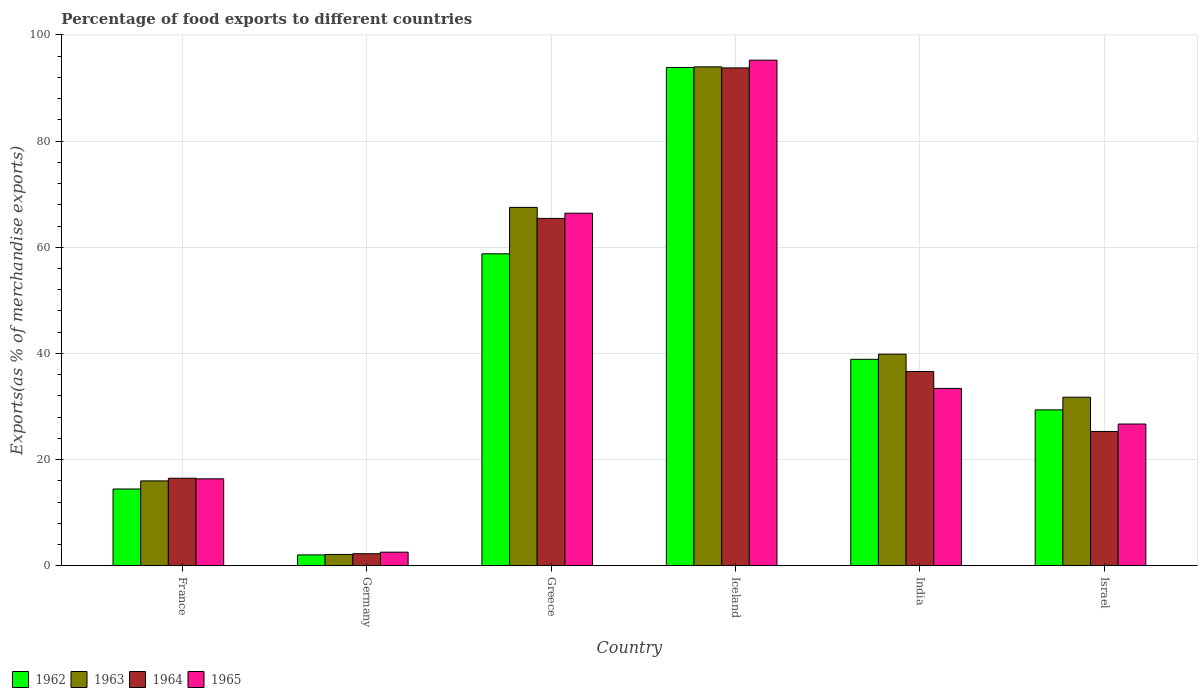How many different coloured bars are there?
Your answer should be very brief. 4. How many groups of bars are there?
Your answer should be compact. 6. Are the number of bars per tick equal to the number of legend labels?
Provide a succinct answer. Yes. What is the label of the 6th group of bars from the left?
Your response must be concise. Israel. What is the percentage of exports to different countries in 1964 in France?
Your answer should be very brief. 16.5. Across all countries, what is the maximum percentage of exports to different countries in 1964?
Provide a short and direct response. 93.79. Across all countries, what is the minimum percentage of exports to different countries in 1962?
Your response must be concise. 2.05. What is the total percentage of exports to different countries in 1962 in the graph?
Your answer should be compact. 237.43. What is the difference between the percentage of exports to different countries in 1963 in Germany and that in Israel?
Make the answer very short. -29.62. What is the difference between the percentage of exports to different countries in 1963 in India and the percentage of exports to different countries in 1965 in Germany?
Make the answer very short. 37.3. What is the average percentage of exports to different countries in 1964 per country?
Provide a short and direct response. 39.99. What is the difference between the percentage of exports to different countries of/in 1962 and percentage of exports to different countries of/in 1964 in Iceland?
Offer a very short reply. 0.08. What is the ratio of the percentage of exports to different countries in 1964 in Greece to that in Iceland?
Offer a very short reply. 0.7. Is the percentage of exports to different countries in 1962 in India less than that in Israel?
Your answer should be compact. No. Is the difference between the percentage of exports to different countries in 1962 in France and Iceland greater than the difference between the percentage of exports to different countries in 1964 in France and Iceland?
Provide a short and direct response. No. What is the difference between the highest and the second highest percentage of exports to different countries in 1965?
Keep it short and to the point. -33.01. What is the difference between the highest and the lowest percentage of exports to different countries in 1962?
Ensure brevity in your answer.  91.82. Is it the case that in every country, the sum of the percentage of exports to different countries in 1963 and percentage of exports to different countries in 1965 is greater than the sum of percentage of exports to different countries in 1964 and percentage of exports to different countries in 1962?
Give a very brief answer. No. What does the 2nd bar from the left in Iceland represents?
Provide a short and direct response. 1963. What does the 1st bar from the right in India represents?
Ensure brevity in your answer.  1965. How many bars are there?
Offer a terse response. 24. How many countries are there in the graph?
Make the answer very short. 6. Does the graph contain any zero values?
Make the answer very short. No. Where does the legend appear in the graph?
Ensure brevity in your answer.  Bottom left. How many legend labels are there?
Give a very brief answer. 4. How are the legend labels stacked?
Your answer should be compact. Horizontal. What is the title of the graph?
Your answer should be compact. Percentage of food exports to different countries. Does "1977" appear as one of the legend labels in the graph?
Give a very brief answer. No. What is the label or title of the Y-axis?
Offer a very short reply. Exports(as % of merchandise exports). What is the Exports(as % of merchandise exports) in 1962 in France?
Make the answer very short. 14.46. What is the Exports(as % of merchandise exports) in 1963 in France?
Ensure brevity in your answer.  15.99. What is the Exports(as % of merchandise exports) in 1964 in France?
Make the answer very short. 16.5. What is the Exports(as % of merchandise exports) in 1965 in France?
Ensure brevity in your answer.  16.38. What is the Exports(as % of merchandise exports) of 1962 in Germany?
Provide a short and direct response. 2.05. What is the Exports(as % of merchandise exports) in 1963 in Germany?
Ensure brevity in your answer.  2.14. What is the Exports(as % of merchandise exports) of 1964 in Germany?
Ensure brevity in your answer.  2.27. What is the Exports(as % of merchandise exports) of 1965 in Germany?
Make the answer very short. 2.57. What is the Exports(as % of merchandise exports) in 1962 in Greece?
Offer a very short reply. 58.77. What is the Exports(as % of merchandise exports) in 1963 in Greece?
Your response must be concise. 67.52. What is the Exports(as % of merchandise exports) in 1964 in Greece?
Offer a very short reply. 65.45. What is the Exports(as % of merchandise exports) in 1965 in Greece?
Keep it short and to the point. 66.42. What is the Exports(as % of merchandise exports) of 1962 in Iceland?
Ensure brevity in your answer.  93.87. What is the Exports(as % of merchandise exports) of 1963 in Iceland?
Provide a succinct answer. 93.99. What is the Exports(as % of merchandise exports) in 1964 in Iceland?
Your response must be concise. 93.79. What is the Exports(as % of merchandise exports) of 1965 in Iceland?
Keep it short and to the point. 95.25. What is the Exports(as % of merchandise exports) of 1962 in India?
Your response must be concise. 38.9. What is the Exports(as % of merchandise exports) of 1963 in India?
Ensure brevity in your answer.  39.86. What is the Exports(as % of merchandise exports) in 1964 in India?
Keep it short and to the point. 36.6. What is the Exports(as % of merchandise exports) of 1965 in India?
Your response must be concise. 33.41. What is the Exports(as % of merchandise exports) of 1962 in Israel?
Give a very brief answer. 29.37. What is the Exports(as % of merchandise exports) of 1963 in Israel?
Make the answer very short. 31.76. What is the Exports(as % of merchandise exports) of 1964 in Israel?
Your answer should be compact. 25.31. What is the Exports(as % of merchandise exports) of 1965 in Israel?
Provide a short and direct response. 26.71. Across all countries, what is the maximum Exports(as % of merchandise exports) in 1962?
Provide a succinct answer. 93.87. Across all countries, what is the maximum Exports(as % of merchandise exports) in 1963?
Your answer should be compact. 93.99. Across all countries, what is the maximum Exports(as % of merchandise exports) in 1964?
Provide a short and direct response. 93.79. Across all countries, what is the maximum Exports(as % of merchandise exports) of 1965?
Your answer should be compact. 95.25. Across all countries, what is the minimum Exports(as % of merchandise exports) in 1962?
Provide a succinct answer. 2.05. Across all countries, what is the minimum Exports(as % of merchandise exports) of 1963?
Offer a very short reply. 2.14. Across all countries, what is the minimum Exports(as % of merchandise exports) in 1964?
Provide a short and direct response. 2.27. Across all countries, what is the minimum Exports(as % of merchandise exports) of 1965?
Provide a short and direct response. 2.57. What is the total Exports(as % of merchandise exports) in 1962 in the graph?
Your answer should be very brief. 237.43. What is the total Exports(as % of merchandise exports) of 1963 in the graph?
Provide a short and direct response. 251.27. What is the total Exports(as % of merchandise exports) in 1964 in the graph?
Provide a succinct answer. 239.92. What is the total Exports(as % of merchandise exports) of 1965 in the graph?
Keep it short and to the point. 240.74. What is the difference between the Exports(as % of merchandise exports) of 1962 in France and that in Germany?
Provide a succinct answer. 12.41. What is the difference between the Exports(as % of merchandise exports) of 1963 in France and that in Germany?
Provide a short and direct response. 13.85. What is the difference between the Exports(as % of merchandise exports) in 1964 in France and that in Germany?
Your answer should be very brief. 14.22. What is the difference between the Exports(as % of merchandise exports) in 1965 in France and that in Germany?
Offer a terse response. 13.82. What is the difference between the Exports(as % of merchandise exports) in 1962 in France and that in Greece?
Make the answer very short. -44.31. What is the difference between the Exports(as % of merchandise exports) in 1963 in France and that in Greece?
Make the answer very short. -51.53. What is the difference between the Exports(as % of merchandise exports) of 1964 in France and that in Greece?
Offer a very short reply. -48.95. What is the difference between the Exports(as % of merchandise exports) in 1965 in France and that in Greece?
Offer a very short reply. -50.04. What is the difference between the Exports(as % of merchandise exports) in 1962 in France and that in Iceland?
Ensure brevity in your answer.  -79.41. What is the difference between the Exports(as % of merchandise exports) in 1963 in France and that in Iceland?
Provide a short and direct response. -78. What is the difference between the Exports(as % of merchandise exports) in 1964 in France and that in Iceland?
Your answer should be compact. -77.29. What is the difference between the Exports(as % of merchandise exports) of 1965 in France and that in Iceland?
Ensure brevity in your answer.  -78.87. What is the difference between the Exports(as % of merchandise exports) of 1962 in France and that in India?
Make the answer very short. -24.43. What is the difference between the Exports(as % of merchandise exports) in 1963 in France and that in India?
Make the answer very short. -23.87. What is the difference between the Exports(as % of merchandise exports) of 1964 in France and that in India?
Offer a very short reply. -20.11. What is the difference between the Exports(as % of merchandise exports) in 1965 in France and that in India?
Ensure brevity in your answer.  -17.03. What is the difference between the Exports(as % of merchandise exports) of 1962 in France and that in Israel?
Provide a short and direct response. -14.91. What is the difference between the Exports(as % of merchandise exports) in 1963 in France and that in Israel?
Ensure brevity in your answer.  -15.77. What is the difference between the Exports(as % of merchandise exports) of 1964 in France and that in Israel?
Give a very brief answer. -8.81. What is the difference between the Exports(as % of merchandise exports) of 1965 in France and that in Israel?
Offer a very short reply. -10.32. What is the difference between the Exports(as % of merchandise exports) in 1962 in Germany and that in Greece?
Offer a terse response. -56.72. What is the difference between the Exports(as % of merchandise exports) of 1963 in Germany and that in Greece?
Your answer should be compact. -65.38. What is the difference between the Exports(as % of merchandise exports) in 1964 in Germany and that in Greece?
Provide a succinct answer. -63.17. What is the difference between the Exports(as % of merchandise exports) of 1965 in Germany and that in Greece?
Your answer should be compact. -63.85. What is the difference between the Exports(as % of merchandise exports) of 1962 in Germany and that in Iceland?
Your answer should be very brief. -91.82. What is the difference between the Exports(as % of merchandise exports) in 1963 in Germany and that in Iceland?
Offer a terse response. -91.85. What is the difference between the Exports(as % of merchandise exports) of 1964 in Germany and that in Iceland?
Ensure brevity in your answer.  -91.52. What is the difference between the Exports(as % of merchandise exports) in 1965 in Germany and that in Iceland?
Provide a succinct answer. -92.68. What is the difference between the Exports(as % of merchandise exports) in 1962 in Germany and that in India?
Keep it short and to the point. -36.84. What is the difference between the Exports(as % of merchandise exports) in 1963 in Germany and that in India?
Your answer should be very brief. -37.73. What is the difference between the Exports(as % of merchandise exports) of 1964 in Germany and that in India?
Provide a succinct answer. -34.33. What is the difference between the Exports(as % of merchandise exports) in 1965 in Germany and that in India?
Provide a succinct answer. -30.85. What is the difference between the Exports(as % of merchandise exports) in 1962 in Germany and that in Israel?
Offer a terse response. -27.32. What is the difference between the Exports(as % of merchandise exports) of 1963 in Germany and that in Israel?
Offer a very short reply. -29.62. What is the difference between the Exports(as % of merchandise exports) in 1964 in Germany and that in Israel?
Your answer should be compact. -23.03. What is the difference between the Exports(as % of merchandise exports) in 1965 in Germany and that in Israel?
Keep it short and to the point. -24.14. What is the difference between the Exports(as % of merchandise exports) of 1962 in Greece and that in Iceland?
Provide a succinct answer. -35.1. What is the difference between the Exports(as % of merchandise exports) in 1963 in Greece and that in Iceland?
Offer a very short reply. -26.47. What is the difference between the Exports(as % of merchandise exports) of 1964 in Greece and that in Iceland?
Your response must be concise. -28.35. What is the difference between the Exports(as % of merchandise exports) in 1965 in Greece and that in Iceland?
Your answer should be very brief. -28.83. What is the difference between the Exports(as % of merchandise exports) in 1962 in Greece and that in India?
Your answer should be very brief. 19.87. What is the difference between the Exports(as % of merchandise exports) in 1963 in Greece and that in India?
Make the answer very short. 27.65. What is the difference between the Exports(as % of merchandise exports) of 1964 in Greece and that in India?
Provide a succinct answer. 28.84. What is the difference between the Exports(as % of merchandise exports) of 1965 in Greece and that in India?
Make the answer very short. 33.01. What is the difference between the Exports(as % of merchandise exports) in 1962 in Greece and that in Israel?
Ensure brevity in your answer.  29.4. What is the difference between the Exports(as % of merchandise exports) of 1963 in Greece and that in Israel?
Give a very brief answer. 35.76. What is the difference between the Exports(as % of merchandise exports) in 1964 in Greece and that in Israel?
Offer a very short reply. 40.14. What is the difference between the Exports(as % of merchandise exports) of 1965 in Greece and that in Israel?
Your response must be concise. 39.71. What is the difference between the Exports(as % of merchandise exports) in 1962 in Iceland and that in India?
Ensure brevity in your answer.  54.98. What is the difference between the Exports(as % of merchandise exports) in 1963 in Iceland and that in India?
Give a very brief answer. 54.13. What is the difference between the Exports(as % of merchandise exports) in 1964 in Iceland and that in India?
Offer a terse response. 57.19. What is the difference between the Exports(as % of merchandise exports) in 1965 in Iceland and that in India?
Your answer should be compact. 61.84. What is the difference between the Exports(as % of merchandise exports) of 1962 in Iceland and that in Israel?
Ensure brevity in your answer.  64.5. What is the difference between the Exports(as % of merchandise exports) of 1963 in Iceland and that in Israel?
Make the answer very short. 62.23. What is the difference between the Exports(as % of merchandise exports) in 1964 in Iceland and that in Israel?
Give a very brief answer. 68.48. What is the difference between the Exports(as % of merchandise exports) in 1965 in Iceland and that in Israel?
Your response must be concise. 68.54. What is the difference between the Exports(as % of merchandise exports) of 1962 in India and that in Israel?
Ensure brevity in your answer.  9.52. What is the difference between the Exports(as % of merchandise exports) of 1963 in India and that in Israel?
Provide a short and direct response. 8.1. What is the difference between the Exports(as % of merchandise exports) of 1964 in India and that in Israel?
Offer a terse response. 11.29. What is the difference between the Exports(as % of merchandise exports) of 1965 in India and that in Israel?
Keep it short and to the point. 6.71. What is the difference between the Exports(as % of merchandise exports) in 1962 in France and the Exports(as % of merchandise exports) in 1963 in Germany?
Give a very brief answer. 12.32. What is the difference between the Exports(as % of merchandise exports) in 1962 in France and the Exports(as % of merchandise exports) in 1964 in Germany?
Your answer should be compact. 12.19. What is the difference between the Exports(as % of merchandise exports) in 1962 in France and the Exports(as % of merchandise exports) in 1965 in Germany?
Ensure brevity in your answer.  11.9. What is the difference between the Exports(as % of merchandise exports) of 1963 in France and the Exports(as % of merchandise exports) of 1964 in Germany?
Provide a short and direct response. 13.72. What is the difference between the Exports(as % of merchandise exports) of 1963 in France and the Exports(as % of merchandise exports) of 1965 in Germany?
Make the answer very short. 13.42. What is the difference between the Exports(as % of merchandise exports) of 1964 in France and the Exports(as % of merchandise exports) of 1965 in Germany?
Offer a terse response. 13.93. What is the difference between the Exports(as % of merchandise exports) of 1962 in France and the Exports(as % of merchandise exports) of 1963 in Greece?
Your answer should be very brief. -53.05. What is the difference between the Exports(as % of merchandise exports) in 1962 in France and the Exports(as % of merchandise exports) in 1964 in Greece?
Provide a short and direct response. -50.98. What is the difference between the Exports(as % of merchandise exports) of 1962 in France and the Exports(as % of merchandise exports) of 1965 in Greece?
Provide a succinct answer. -51.96. What is the difference between the Exports(as % of merchandise exports) of 1963 in France and the Exports(as % of merchandise exports) of 1964 in Greece?
Offer a very short reply. -49.45. What is the difference between the Exports(as % of merchandise exports) in 1963 in France and the Exports(as % of merchandise exports) in 1965 in Greece?
Make the answer very short. -50.43. What is the difference between the Exports(as % of merchandise exports) in 1964 in France and the Exports(as % of merchandise exports) in 1965 in Greece?
Your answer should be compact. -49.93. What is the difference between the Exports(as % of merchandise exports) in 1962 in France and the Exports(as % of merchandise exports) in 1963 in Iceland?
Your answer should be compact. -79.53. What is the difference between the Exports(as % of merchandise exports) in 1962 in France and the Exports(as % of merchandise exports) in 1964 in Iceland?
Offer a terse response. -79.33. What is the difference between the Exports(as % of merchandise exports) in 1962 in France and the Exports(as % of merchandise exports) in 1965 in Iceland?
Ensure brevity in your answer.  -80.79. What is the difference between the Exports(as % of merchandise exports) of 1963 in France and the Exports(as % of merchandise exports) of 1964 in Iceland?
Make the answer very short. -77.8. What is the difference between the Exports(as % of merchandise exports) of 1963 in France and the Exports(as % of merchandise exports) of 1965 in Iceland?
Ensure brevity in your answer.  -79.26. What is the difference between the Exports(as % of merchandise exports) in 1964 in France and the Exports(as % of merchandise exports) in 1965 in Iceland?
Your answer should be compact. -78.75. What is the difference between the Exports(as % of merchandise exports) in 1962 in France and the Exports(as % of merchandise exports) in 1963 in India?
Make the answer very short. -25.4. What is the difference between the Exports(as % of merchandise exports) in 1962 in France and the Exports(as % of merchandise exports) in 1964 in India?
Keep it short and to the point. -22.14. What is the difference between the Exports(as % of merchandise exports) of 1962 in France and the Exports(as % of merchandise exports) of 1965 in India?
Provide a short and direct response. -18.95. What is the difference between the Exports(as % of merchandise exports) of 1963 in France and the Exports(as % of merchandise exports) of 1964 in India?
Ensure brevity in your answer.  -20.61. What is the difference between the Exports(as % of merchandise exports) of 1963 in France and the Exports(as % of merchandise exports) of 1965 in India?
Provide a succinct answer. -17.42. What is the difference between the Exports(as % of merchandise exports) of 1964 in France and the Exports(as % of merchandise exports) of 1965 in India?
Your answer should be compact. -16.92. What is the difference between the Exports(as % of merchandise exports) in 1962 in France and the Exports(as % of merchandise exports) in 1963 in Israel?
Offer a terse response. -17.3. What is the difference between the Exports(as % of merchandise exports) of 1962 in France and the Exports(as % of merchandise exports) of 1964 in Israel?
Offer a very short reply. -10.85. What is the difference between the Exports(as % of merchandise exports) of 1962 in France and the Exports(as % of merchandise exports) of 1965 in Israel?
Make the answer very short. -12.24. What is the difference between the Exports(as % of merchandise exports) in 1963 in France and the Exports(as % of merchandise exports) in 1964 in Israel?
Ensure brevity in your answer.  -9.32. What is the difference between the Exports(as % of merchandise exports) in 1963 in France and the Exports(as % of merchandise exports) in 1965 in Israel?
Keep it short and to the point. -10.71. What is the difference between the Exports(as % of merchandise exports) of 1964 in France and the Exports(as % of merchandise exports) of 1965 in Israel?
Provide a succinct answer. -10.21. What is the difference between the Exports(as % of merchandise exports) in 1962 in Germany and the Exports(as % of merchandise exports) in 1963 in Greece?
Make the answer very short. -65.47. What is the difference between the Exports(as % of merchandise exports) of 1962 in Germany and the Exports(as % of merchandise exports) of 1964 in Greece?
Ensure brevity in your answer.  -63.39. What is the difference between the Exports(as % of merchandise exports) of 1962 in Germany and the Exports(as % of merchandise exports) of 1965 in Greece?
Provide a short and direct response. -64.37. What is the difference between the Exports(as % of merchandise exports) in 1963 in Germany and the Exports(as % of merchandise exports) in 1964 in Greece?
Your response must be concise. -63.31. What is the difference between the Exports(as % of merchandise exports) of 1963 in Germany and the Exports(as % of merchandise exports) of 1965 in Greece?
Provide a succinct answer. -64.28. What is the difference between the Exports(as % of merchandise exports) in 1964 in Germany and the Exports(as % of merchandise exports) in 1965 in Greece?
Offer a terse response. -64.15. What is the difference between the Exports(as % of merchandise exports) in 1962 in Germany and the Exports(as % of merchandise exports) in 1963 in Iceland?
Provide a short and direct response. -91.94. What is the difference between the Exports(as % of merchandise exports) of 1962 in Germany and the Exports(as % of merchandise exports) of 1964 in Iceland?
Keep it short and to the point. -91.74. What is the difference between the Exports(as % of merchandise exports) of 1962 in Germany and the Exports(as % of merchandise exports) of 1965 in Iceland?
Make the answer very short. -93.2. What is the difference between the Exports(as % of merchandise exports) in 1963 in Germany and the Exports(as % of merchandise exports) in 1964 in Iceland?
Give a very brief answer. -91.65. What is the difference between the Exports(as % of merchandise exports) in 1963 in Germany and the Exports(as % of merchandise exports) in 1965 in Iceland?
Offer a terse response. -93.11. What is the difference between the Exports(as % of merchandise exports) of 1964 in Germany and the Exports(as % of merchandise exports) of 1965 in Iceland?
Give a very brief answer. -92.98. What is the difference between the Exports(as % of merchandise exports) of 1962 in Germany and the Exports(as % of merchandise exports) of 1963 in India?
Offer a terse response. -37.81. What is the difference between the Exports(as % of merchandise exports) of 1962 in Germany and the Exports(as % of merchandise exports) of 1964 in India?
Your answer should be very brief. -34.55. What is the difference between the Exports(as % of merchandise exports) of 1962 in Germany and the Exports(as % of merchandise exports) of 1965 in India?
Ensure brevity in your answer.  -31.36. What is the difference between the Exports(as % of merchandise exports) in 1963 in Germany and the Exports(as % of merchandise exports) in 1964 in India?
Provide a short and direct response. -34.46. What is the difference between the Exports(as % of merchandise exports) of 1963 in Germany and the Exports(as % of merchandise exports) of 1965 in India?
Give a very brief answer. -31.27. What is the difference between the Exports(as % of merchandise exports) of 1964 in Germany and the Exports(as % of merchandise exports) of 1965 in India?
Ensure brevity in your answer.  -31.14. What is the difference between the Exports(as % of merchandise exports) in 1962 in Germany and the Exports(as % of merchandise exports) in 1963 in Israel?
Offer a very short reply. -29.71. What is the difference between the Exports(as % of merchandise exports) of 1962 in Germany and the Exports(as % of merchandise exports) of 1964 in Israel?
Your response must be concise. -23.26. What is the difference between the Exports(as % of merchandise exports) in 1962 in Germany and the Exports(as % of merchandise exports) in 1965 in Israel?
Your answer should be very brief. -24.66. What is the difference between the Exports(as % of merchandise exports) of 1963 in Germany and the Exports(as % of merchandise exports) of 1964 in Israel?
Your answer should be compact. -23.17. What is the difference between the Exports(as % of merchandise exports) of 1963 in Germany and the Exports(as % of merchandise exports) of 1965 in Israel?
Provide a short and direct response. -24.57. What is the difference between the Exports(as % of merchandise exports) of 1964 in Germany and the Exports(as % of merchandise exports) of 1965 in Israel?
Your answer should be compact. -24.43. What is the difference between the Exports(as % of merchandise exports) of 1962 in Greece and the Exports(as % of merchandise exports) of 1963 in Iceland?
Provide a short and direct response. -35.22. What is the difference between the Exports(as % of merchandise exports) of 1962 in Greece and the Exports(as % of merchandise exports) of 1964 in Iceland?
Your answer should be compact. -35.02. What is the difference between the Exports(as % of merchandise exports) of 1962 in Greece and the Exports(as % of merchandise exports) of 1965 in Iceland?
Your response must be concise. -36.48. What is the difference between the Exports(as % of merchandise exports) of 1963 in Greece and the Exports(as % of merchandise exports) of 1964 in Iceland?
Offer a very short reply. -26.27. What is the difference between the Exports(as % of merchandise exports) of 1963 in Greece and the Exports(as % of merchandise exports) of 1965 in Iceland?
Your response must be concise. -27.73. What is the difference between the Exports(as % of merchandise exports) of 1964 in Greece and the Exports(as % of merchandise exports) of 1965 in Iceland?
Offer a terse response. -29.8. What is the difference between the Exports(as % of merchandise exports) in 1962 in Greece and the Exports(as % of merchandise exports) in 1963 in India?
Make the answer very short. 18.91. What is the difference between the Exports(as % of merchandise exports) in 1962 in Greece and the Exports(as % of merchandise exports) in 1964 in India?
Keep it short and to the point. 22.17. What is the difference between the Exports(as % of merchandise exports) of 1962 in Greece and the Exports(as % of merchandise exports) of 1965 in India?
Offer a very short reply. 25.36. What is the difference between the Exports(as % of merchandise exports) in 1963 in Greece and the Exports(as % of merchandise exports) in 1964 in India?
Your answer should be compact. 30.92. What is the difference between the Exports(as % of merchandise exports) of 1963 in Greece and the Exports(as % of merchandise exports) of 1965 in India?
Offer a very short reply. 34.1. What is the difference between the Exports(as % of merchandise exports) in 1964 in Greece and the Exports(as % of merchandise exports) in 1965 in India?
Offer a terse response. 32.03. What is the difference between the Exports(as % of merchandise exports) in 1962 in Greece and the Exports(as % of merchandise exports) in 1963 in Israel?
Give a very brief answer. 27.01. What is the difference between the Exports(as % of merchandise exports) in 1962 in Greece and the Exports(as % of merchandise exports) in 1964 in Israel?
Offer a very short reply. 33.46. What is the difference between the Exports(as % of merchandise exports) in 1962 in Greece and the Exports(as % of merchandise exports) in 1965 in Israel?
Provide a short and direct response. 32.06. What is the difference between the Exports(as % of merchandise exports) of 1963 in Greece and the Exports(as % of merchandise exports) of 1964 in Israel?
Provide a succinct answer. 42.21. What is the difference between the Exports(as % of merchandise exports) in 1963 in Greece and the Exports(as % of merchandise exports) in 1965 in Israel?
Your answer should be compact. 40.81. What is the difference between the Exports(as % of merchandise exports) of 1964 in Greece and the Exports(as % of merchandise exports) of 1965 in Israel?
Your answer should be compact. 38.74. What is the difference between the Exports(as % of merchandise exports) of 1962 in Iceland and the Exports(as % of merchandise exports) of 1963 in India?
Keep it short and to the point. 54.01. What is the difference between the Exports(as % of merchandise exports) in 1962 in Iceland and the Exports(as % of merchandise exports) in 1964 in India?
Give a very brief answer. 57.27. What is the difference between the Exports(as % of merchandise exports) of 1962 in Iceland and the Exports(as % of merchandise exports) of 1965 in India?
Offer a terse response. 60.46. What is the difference between the Exports(as % of merchandise exports) in 1963 in Iceland and the Exports(as % of merchandise exports) in 1964 in India?
Ensure brevity in your answer.  57.39. What is the difference between the Exports(as % of merchandise exports) in 1963 in Iceland and the Exports(as % of merchandise exports) in 1965 in India?
Your answer should be very brief. 60.58. What is the difference between the Exports(as % of merchandise exports) of 1964 in Iceland and the Exports(as % of merchandise exports) of 1965 in India?
Make the answer very short. 60.38. What is the difference between the Exports(as % of merchandise exports) of 1962 in Iceland and the Exports(as % of merchandise exports) of 1963 in Israel?
Your response must be concise. 62.11. What is the difference between the Exports(as % of merchandise exports) in 1962 in Iceland and the Exports(as % of merchandise exports) in 1964 in Israel?
Provide a short and direct response. 68.57. What is the difference between the Exports(as % of merchandise exports) in 1962 in Iceland and the Exports(as % of merchandise exports) in 1965 in Israel?
Provide a short and direct response. 67.17. What is the difference between the Exports(as % of merchandise exports) of 1963 in Iceland and the Exports(as % of merchandise exports) of 1964 in Israel?
Keep it short and to the point. 68.68. What is the difference between the Exports(as % of merchandise exports) of 1963 in Iceland and the Exports(as % of merchandise exports) of 1965 in Israel?
Offer a very short reply. 67.28. What is the difference between the Exports(as % of merchandise exports) of 1964 in Iceland and the Exports(as % of merchandise exports) of 1965 in Israel?
Make the answer very short. 67.08. What is the difference between the Exports(as % of merchandise exports) in 1962 in India and the Exports(as % of merchandise exports) in 1963 in Israel?
Provide a succinct answer. 7.14. What is the difference between the Exports(as % of merchandise exports) of 1962 in India and the Exports(as % of merchandise exports) of 1964 in Israel?
Provide a short and direct response. 13.59. What is the difference between the Exports(as % of merchandise exports) in 1962 in India and the Exports(as % of merchandise exports) in 1965 in Israel?
Offer a very short reply. 12.19. What is the difference between the Exports(as % of merchandise exports) in 1963 in India and the Exports(as % of merchandise exports) in 1964 in Israel?
Give a very brief answer. 14.56. What is the difference between the Exports(as % of merchandise exports) in 1963 in India and the Exports(as % of merchandise exports) in 1965 in Israel?
Ensure brevity in your answer.  13.16. What is the difference between the Exports(as % of merchandise exports) of 1964 in India and the Exports(as % of merchandise exports) of 1965 in Israel?
Give a very brief answer. 9.89. What is the average Exports(as % of merchandise exports) of 1962 per country?
Offer a very short reply. 39.57. What is the average Exports(as % of merchandise exports) of 1963 per country?
Ensure brevity in your answer.  41.88. What is the average Exports(as % of merchandise exports) of 1964 per country?
Make the answer very short. 39.99. What is the average Exports(as % of merchandise exports) in 1965 per country?
Offer a very short reply. 40.12. What is the difference between the Exports(as % of merchandise exports) in 1962 and Exports(as % of merchandise exports) in 1963 in France?
Give a very brief answer. -1.53. What is the difference between the Exports(as % of merchandise exports) in 1962 and Exports(as % of merchandise exports) in 1964 in France?
Offer a terse response. -2.03. What is the difference between the Exports(as % of merchandise exports) of 1962 and Exports(as % of merchandise exports) of 1965 in France?
Make the answer very short. -1.92. What is the difference between the Exports(as % of merchandise exports) of 1963 and Exports(as % of merchandise exports) of 1964 in France?
Offer a terse response. -0.5. What is the difference between the Exports(as % of merchandise exports) in 1963 and Exports(as % of merchandise exports) in 1965 in France?
Your response must be concise. -0.39. What is the difference between the Exports(as % of merchandise exports) in 1964 and Exports(as % of merchandise exports) in 1965 in France?
Provide a short and direct response. 0.11. What is the difference between the Exports(as % of merchandise exports) of 1962 and Exports(as % of merchandise exports) of 1963 in Germany?
Ensure brevity in your answer.  -0.09. What is the difference between the Exports(as % of merchandise exports) in 1962 and Exports(as % of merchandise exports) in 1964 in Germany?
Keep it short and to the point. -0.22. What is the difference between the Exports(as % of merchandise exports) of 1962 and Exports(as % of merchandise exports) of 1965 in Germany?
Offer a terse response. -0.52. What is the difference between the Exports(as % of merchandise exports) of 1963 and Exports(as % of merchandise exports) of 1964 in Germany?
Give a very brief answer. -0.14. What is the difference between the Exports(as % of merchandise exports) of 1963 and Exports(as % of merchandise exports) of 1965 in Germany?
Provide a short and direct response. -0.43. What is the difference between the Exports(as % of merchandise exports) of 1964 and Exports(as % of merchandise exports) of 1965 in Germany?
Provide a short and direct response. -0.29. What is the difference between the Exports(as % of merchandise exports) of 1962 and Exports(as % of merchandise exports) of 1963 in Greece?
Your answer should be very brief. -8.75. What is the difference between the Exports(as % of merchandise exports) of 1962 and Exports(as % of merchandise exports) of 1964 in Greece?
Keep it short and to the point. -6.67. What is the difference between the Exports(as % of merchandise exports) of 1962 and Exports(as % of merchandise exports) of 1965 in Greece?
Keep it short and to the point. -7.65. What is the difference between the Exports(as % of merchandise exports) in 1963 and Exports(as % of merchandise exports) in 1964 in Greece?
Your answer should be very brief. 2.07. What is the difference between the Exports(as % of merchandise exports) in 1963 and Exports(as % of merchandise exports) in 1965 in Greece?
Provide a short and direct response. 1.1. What is the difference between the Exports(as % of merchandise exports) of 1964 and Exports(as % of merchandise exports) of 1965 in Greece?
Make the answer very short. -0.98. What is the difference between the Exports(as % of merchandise exports) in 1962 and Exports(as % of merchandise exports) in 1963 in Iceland?
Offer a very short reply. -0.12. What is the difference between the Exports(as % of merchandise exports) of 1962 and Exports(as % of merchandise exports) of 1964 in Iceland?
Your answer should be compact. 0.08. What is the difference between the Exports(as % of merchandise exports) of 1962 and Exports(as % of merchandise exports) of 1965 in Iceland?
Keep it short and to the point. -1.38. What is the difference between the Exports(as % of merchandise exports) in 1963 and Exports(as % of merchandise exports) in 1964 in Iceland?
Offer a very short reply. 0.2. What is the difference between the Exports(as % of merchandise exports) of 1963 and Exports(as % of merchandise exports) of 1965 in Iceland?
Your answer should be very brief. -1.26. What is the difference between the Exports(as % of merchandise exports) in 1964 and Exports(as % of merchandise exports) in 1965 in Iceland?
Offer a very short reply. -1.46. What is the difference between the Exports(as % of merchandise exports) of 1962 and Exports(as % of merchandise exports) of 1963 in India?
Keep it short and to the point. -0.97. What is the difference between the Exports(as % of merchandise exports) of 1962 and Exports(as % of merchandise exports) of 1964 in India?
Offer a very short reply. 2.29. What is the difference between the Exports(as % of merchandise exports) of 1962 and Exports(as % of merchandise exports) of 1965 in India?
Your response must be concise. 5.48. What is the difference between the Exports(as % of merchandise exports) in 1963 and Exports(as % of merchandise exports) in 1964 in India?
Your answer should be very brief. 3.26. What is the difference between the Exports(as % of merchandise exports) in 1963 and Exports(as % of merchandise exports) in 1965 in India?
Give a very brief answer. 6.45. What is the difference between the Exports(as % of merchandise exports) in 1964 and Exports(as % of merchandise exports) in 1965 in India?
Provide a short and direct response. 3.19. What is the difference between the Exports(as % of merchandise exports) in 1962 and Exports(as % of merchandise exports) in 1963 in Israel?
Offer a very short reply. -2.39. What is the difference between the Exports(as % of merchandise exports) in 1962 and Exports(as % of merchandise exports) in 1964 in Israel?
Keep it short and to the point. 4.07. What is the difference between the Exports(as % of merchandise exports) in 1962 and Exports(as % of merchandise exports) in 1965 in Israel?
Offer a very short reply. 2.67. What is the difference between the Exports(as % of merchandise exports) in 1963 and Exports(as % of merchandise exports) in 1964 in Israel?
Give a very brief answer. 6.45. What is the difference between the Exports(as % of merchandise exports) in 1963 and Exports(as % of merchandise exports) in 1965 in Israel?
Provide a short and direct response. 5.05. What is the difference between the Exports(as % of merchandise exports) in 1964 and Exports(as % of merchandise exports) in 1965 in Israel?
Provide a short and direct response. -1.4. What is the ratio of the Exports(as % of merchandise exports) of 1962 in France to that in Germany?
Your answer should be compact. 7.05. What is the ratio of the Exports(as % of merchandise exports) of 1963 in France to that in Germany?
Your response must be concise. 7.48. What is the ratio of the Exports(as % of merchandise exports) in 1964 in France to that in Germany?
Make the answer very short. 7.25. What is the ratio of the Exports(as % of merchandise exports) in 1965 in France to that in Germany?
Ensure brevity in your answer.  6.38. What is the ratio of the Exports(as % of merchandise exports) of 1962 in France to that in Greece?
Provide a short and direct response. 0.25. What is the ratio of the Exports(as % of merchandise exports) in 1963 in France to that in Greece?
Your answer should be very brief. 0.24. What is the ratio of the Exports(as % of merchandise exports) in 1964 in France to that in Greece?
Provide a succinct answer. 0.25. What is the ratio of the Exports(as % of merchandise exports) of 1965 in France to that in Greece?
Offer a very short reply. 0.25. What is the ratio of the Exports(as % of merchandise exports) of 1962 in France to that in Iceland?
Ensure brevity in your answer.  0.15. What is the ratio of the Exports(as % of merchandise exports) of 1963 in France to that in Iceland?
Keep it short and to the point. 0.17. What is the ratio of the Exports(as % of merchandise exports) in 1964 in France to that in Iceland?
Offer a very short reply. 0.18. What is the ratio of the Exports(as % of merchandise exports) in 1965 in France to that in Iceland?
Your response must be concise. 0.17. What is the ratio of the Exports(as % of merchandise exports) in 1962 in France to that in India?
Provide a short and direct response. 0.37. What is the ratio of the Exports(as % of merchandise exports) of 1963 in France to that in India?
Provide a succinct answer. 0.4. What is the ratio of the Exports(as % of merchandise exports) in 1964 in France to that in India?
Provide a short and direct response. 0.45. What is the ratio of the Exports(as % of merchandise exports) in 1965 in France to that in India?
Provide a short and direct response. 0.49. What is the ratio of the Exports(as % of merchandise exports) of 1962 in France to that in Israel?
Make the answer very short. 0.49. What is the ratio of the Exports(as % of merchandise exports) in 1963 in France to that in Israel?
Offer a very short reply. 0.5. What is the ratio of the Exports(as % of merchandise exports) in 1964 in France to that in Israel?
Your response must be concise. 0.65. What is the ratio of the Exports(as % of merchandise exports) in 1965 in France to that in Israel?
Provide a succinct answer. 0.61. What is the ratio of the Exports(as % of merchandise exports) in 1962 in Germany to that in Greece?
Keep it short and to the point. 0.03. What is the ratio of the Exports(as % of merchandise exports) in 1963 in Germany to that in Greece?
Give a very brief answer. 0.03. What is the ratio of the Exports(as % of merchandise exports) of 1964 in Germany to that in Greece?
Provide a succinct answer. 0.03. What is the ratio of the Exports(as % of merchandise exports) in 1965 in Germany to that in Greece?
Provide a succinct answer. 0.04. What is the ratio of the Exports(as % of merchandise exports) in 1962 in Germany to that in Iceland?
Ensure brevity in your answer.  0.02. What is the ratio of the Exports(as % of merchandise exports) in 1963 in Germany to that in Iceland?
Give a very brief answer. 0.02. What is the ratio of the Exports(as % of merchandise exports) of 1964 in Germany to that in Iceland?
Provide a succinct answer. 0.02. What is the ratio of the Exports(as % of merchandise exports) in 1965 in Germany to that in Iceland?
Keep it short and to the point. 0.03. What is the ratio of the Exports(as % of merchandise exports) in 1962 in Germany to that in India?
Give a very brief answer. 0.05. What is the ratio of the Exports(as % of merchandise exports) of 1963 in Germany to that in India?
Ensure brevity in your answer.  0.05. What is the ratio of the Exports(as % of merchandise exports) of 1964 in Germany to that in India?
Offer a terse response. 0.06. What is the ratio of the Exports(as % of merchandise exports) of 1965 in Germany to that in India?
Your response must be concise. 0.08. What is the ratio of the Exports(as % of merchandise exports) of 1962 in Germany to that in Israel?
Keep it short and to the point. 0.07. What is the ratio of the Exports(as % of merchandise exports) in 1963 in Germany to that in Israel?
Offer a very short reply. 0.07. What is the ratio of the Exports(as % of merchandise exports) in 1964 in Germany to that in Israel?
Give a very brief answer. 0.09. What is the ratio of the Exports(as % of merchandise exports) of 1965 in Germany to that in Israel?
Offer a very short reply. 0.1. What is the ratio of the Exports(as % of merchandise exports) of 1962 in Greece to that in Iceland?
Make the answer very short. 0.63. What is the ratio of the Exports(as % of merchandise exports) in 1963 in Greece to that in Iceland?
Offer a very short reply. 0.72. What is the ratio of the Exports(as % of merchandise exports) in 1964 in Greece to that in Iceland?
Your answer should be very brief. 0.7. What is the ratio of the Exports(as % of merchandise exports) in 1965 in Greece to that in Iceland?
Offer a very short reply. 0.7. What is the ratio of the Exports(as % of merchandise exports) in 1962 in Greece to that in India?
Ensure brevity in your answer.  1.51. What is the ratio of the Exports(as % of merchandise exports) of 1963 in Greece to that in India?
Ensure brevity in your answer.  1.69. What is the ratio of the Exports(as % of merchandise exports) in 1964 in Greece to that in India?
Offer a very short reply. 1.79. What is the ratio of the Exports(as % of merchandise exports) in 1965 in Greece to that in India?
Your answer should be compact. 1.99. What is the ratio of the Exports(as % of merchandise exports) in 1962 in Greece to that in Israel?
Ensure brevity in your answer.  2. What is the ratio of the Exports(as % of merchandise exports) of 1963 in Greece to that in Israel?
Your response must be concise. 2.13. What is the ratio of the Exports(as % of merchandise exports) in 1964 in Greece to that in Israel?
Make the answer very short. 2.59. What is the ratio of the Exports(as % of merchandise exports) in 1965 in Greece to that in Israel?
Your answer should be compact. 2.49. What is the ratio of the Exports(as % of merchandise exports) in 1962 in Iceland to that in India?
Provide a short and direct response. 2.41. What is the ratio of the Exports(as % of merchandise exports) in 1963 in Iceland to that in India?
Keep it short and to the point. 2.36. What is the ratio of the Exports(as % of merchandise exports) of 1964 in Iceland to that in India?
Your response must be concise. 2.56. What is the ratio of the Exports(as % of merchandise exports) of 1965 in Iceland to that in India?
Your response must be concise. 2.85. What is the ratio of the Exports(as % of merchandise exports) of 1962 in Iceland to that in Israel?
Give a very brief answer. 3.2. What is the ratio of the Exports(as % of merchandise exports) in 1963 in Iceland to that in Israel?
Your response must be concise. 2.96. What is the ratio of the Exports(as % of merchandise exports) of 1964 in Iceland to that in Israel?
Your answer should be very brief. 3.71. What is the ratio of the Exports(as % of merchandise exports) of 1965 in Iceland to that in Israel?
Offer a very short reply. 3.57. What is the ratio of the Exports(as % of merchandise exports) of 1962 in India to that in Israel?
Make the answer very short. 1.32. What is the ratio of the Exports(as % of merchandise exports) of 1963 in India to that in Israel?
Ensure brevity in your answer.  1.26. What is the ratio of the Exports(as % of merchandise exports) in 1964 in India to that in Israel?
Provide a short and direct response. 1.45. What is the ratio of the Exports(as % of merchandise exports) in 1965 in India to that in Israel?
Your response must be concise. 1.25. What is the difference between the highest and the second highest Exports(as % of merchandise exports) in 1962?
Make the answer very short. 35.1. What is the difference between the highest and the second highest Exports(as % of merchandise exports) in 1963?
Your answer should be very brief. 26.47. What is the difference between the highest and the second highest Exports(as % of merchandise exports) in 1964?
Provide a short and direct response. 28.35. What is the difference between the highest and the second highest Exports(as % of merchandise exports) in 1965?
Your response must be concise. 28.83. What is the difference between the highest and the lowest Exports(as % of merchandise exports) of 1962?
Your answer should be very brief. 91.82. What is the difference between the highest and the lowest Exports(as % of merchandise exports) in 1963?
Your response must be concise. 91.85. What is the difference between the highest and the lowest Exports(as % of merchandise exports) of 1964?
Your answer should be compact. 91.52. What is the difference between the highest and the lowest Exports(as % of merchandise exports) of 1965?
Your response must be concise. 92.68. 